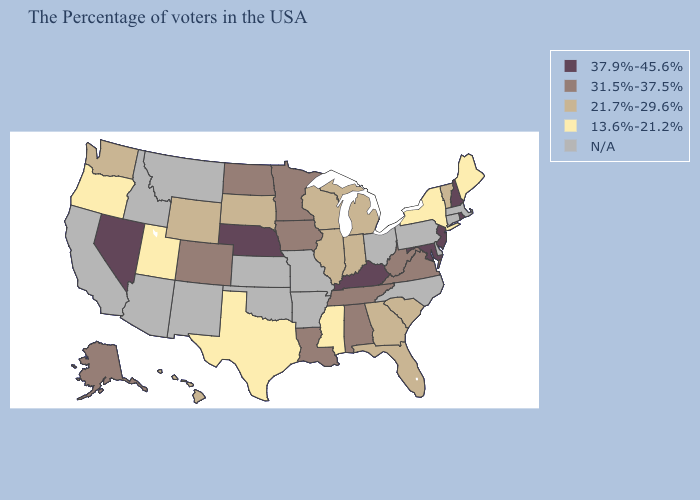Name the states that have a value in the range 31.5%-37.5%?
Be succinct. Virginia, West Virginia, Alabama, Tennessee, Louisiana, Minnesota, Iowa, North Dakota, Colorado, Alaska. What is the value of California?
Be succinct. N/A. Among the states that border Tennessee , which have the highest value?
Write a very short answer. Kentucky. What is the value of Pennsylvania?
Answer briefly. N/A. Name the states that have a value in the range N/A?
Keep it brief. Massachusetts, Connecticut, Delaware, Pennsylvania, North Carolina, Ohio, Missouri, Arkansas, Kansas, Oklahoma, New Mexico, Montana, Arizona, Idaho, California. What is the value of Iowa?
Be succinct. 31.5%-37.5%. Name the states that have a value in the range 37.9%-45.6%?
Be succinct. Rhode Island, New Hampshire, New Jersey, Maryland, Kentucky, Nebraska, Nevada. What is the value of Connecticut?
Quick response, please. N/A. What is the value of Ohio?
Concise answer only. N/A. Is the legend a continuous bar?
Keep it brief. No. What is the value of Hawaii?
Write a very short answer. 21.7%-29.6%. Which states hav the highest value in the South?
Be succinct. Maryland, Kentucky. 